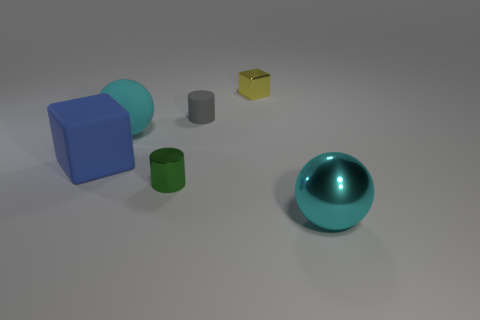There is a shiny object that is the same color as the big rubber sphere; what size is it?
Give a very brief answer. Large. Are there more metallic cylinders left of the big block than gray things?
Your answer should be very brief. No. Are there any large matte cylinders that have the same color as the small metal cylinder?
Ensure brevity in your answer.  No. What color is the metallic block that is the same size as the green shiny thing?
Keep it short and to the point. Yellow. What number of cyan matte spheres are left of the cylinder that is behind the blue thing?
Provide a succinct answer. 1. How many things are objects that are behind the cyan rubber object or green matte cylinders?
Your answer should be very brief. 2. What number of big blocks have the same material as the green cylinder?
Give a very brief answer. 0. What is the shape of the large object that is the same color as the big rubber sphere?
Give a very brief answer. Sphere. Are there an equal number of big rubber balls in front of the metallic ball and tiny blue matte balls?
Ensure brevity in your answer.  Yes. There is a sphere that is in front of the metal cylinder; what size is it?
Your answer should be compact. Large. 